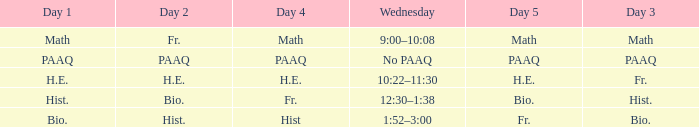What is the Wednesday when day 3 is math? 9:00–10:08. 